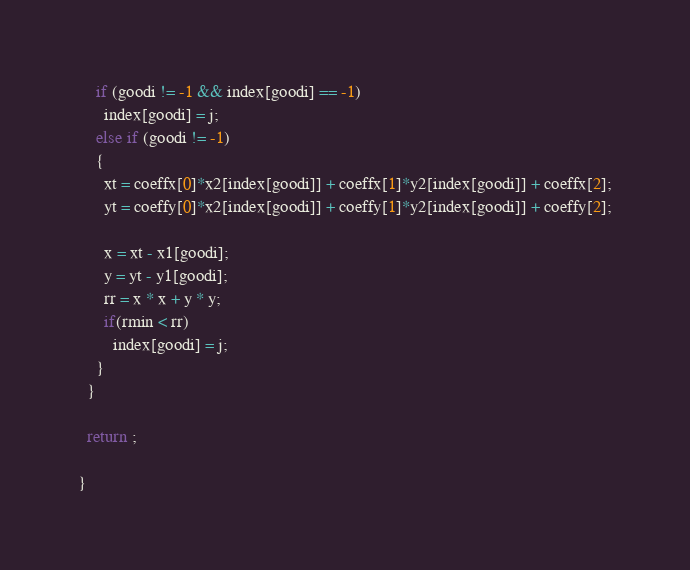<code> <loc_0><loc_0><loc_500><loc_500><_C_>    if (goodi != -1 && index[goodi] == -1)
      index[goodi] = j;
    else if (goodi != -1)
    {
      xt = coeffx[0]*x2[index[goodi]] + coeffx[1]*y2[index[goodi]] + coeffx[2];
      yt = coeffy[0]*x2[index[goodi]] + coeffy[1]*y2[index[goodi]] + coeffy[2];

      x = xt - x1[goodi];
      y = yt - y1[goodi];
      rr = x * x + y * y;
      if(rmin < rr)
        index[goodi] = j;
    }   
  }
  
  return ;

}

</code> 